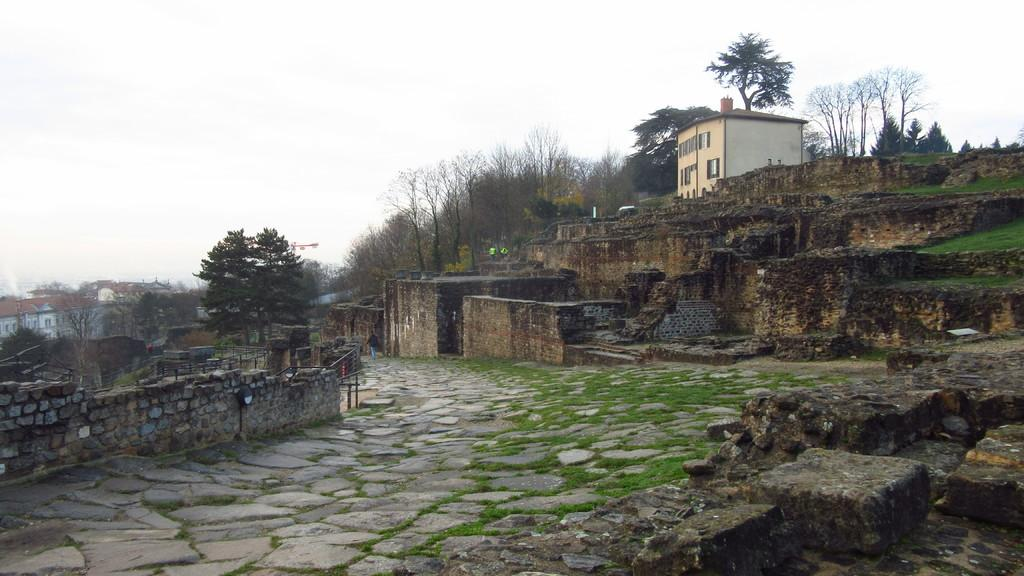What type of structures can be seen in the image? There are buildings in the image. What other natural elements are present in the image? There are trees in the image. What type of man-made barriers are visible in the image? There are walls in the image. What can be seen in the distance in the image? The sky is visible in the background of the image. What type of ground cover is at the bottom of the image? There is grass at the bottom of the image. How many dogs are sitting on the book in the image? There are no dogs or books present in the image. What type of mine is visible in the image? There is no mine visible in the image. 